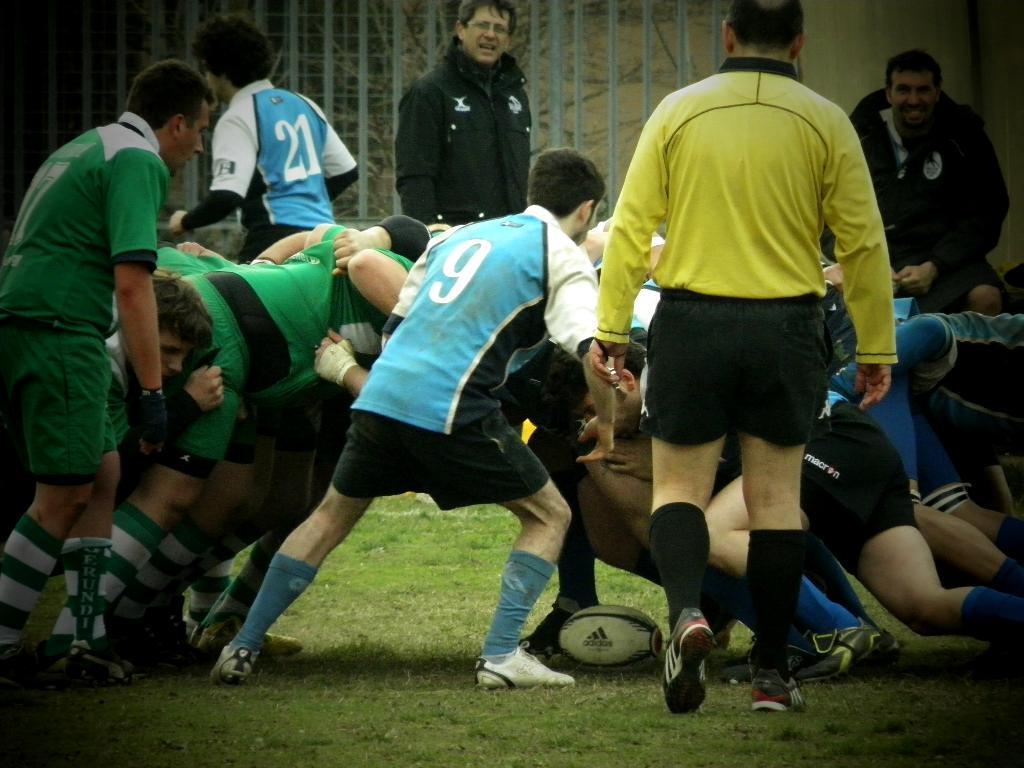Could you give a brief overview of what you see in this image? In the image in the center we can see one ball and few people were standing and they were in different color t shirts. In the background there is a wall,fence,trees,grass and one person standing. 